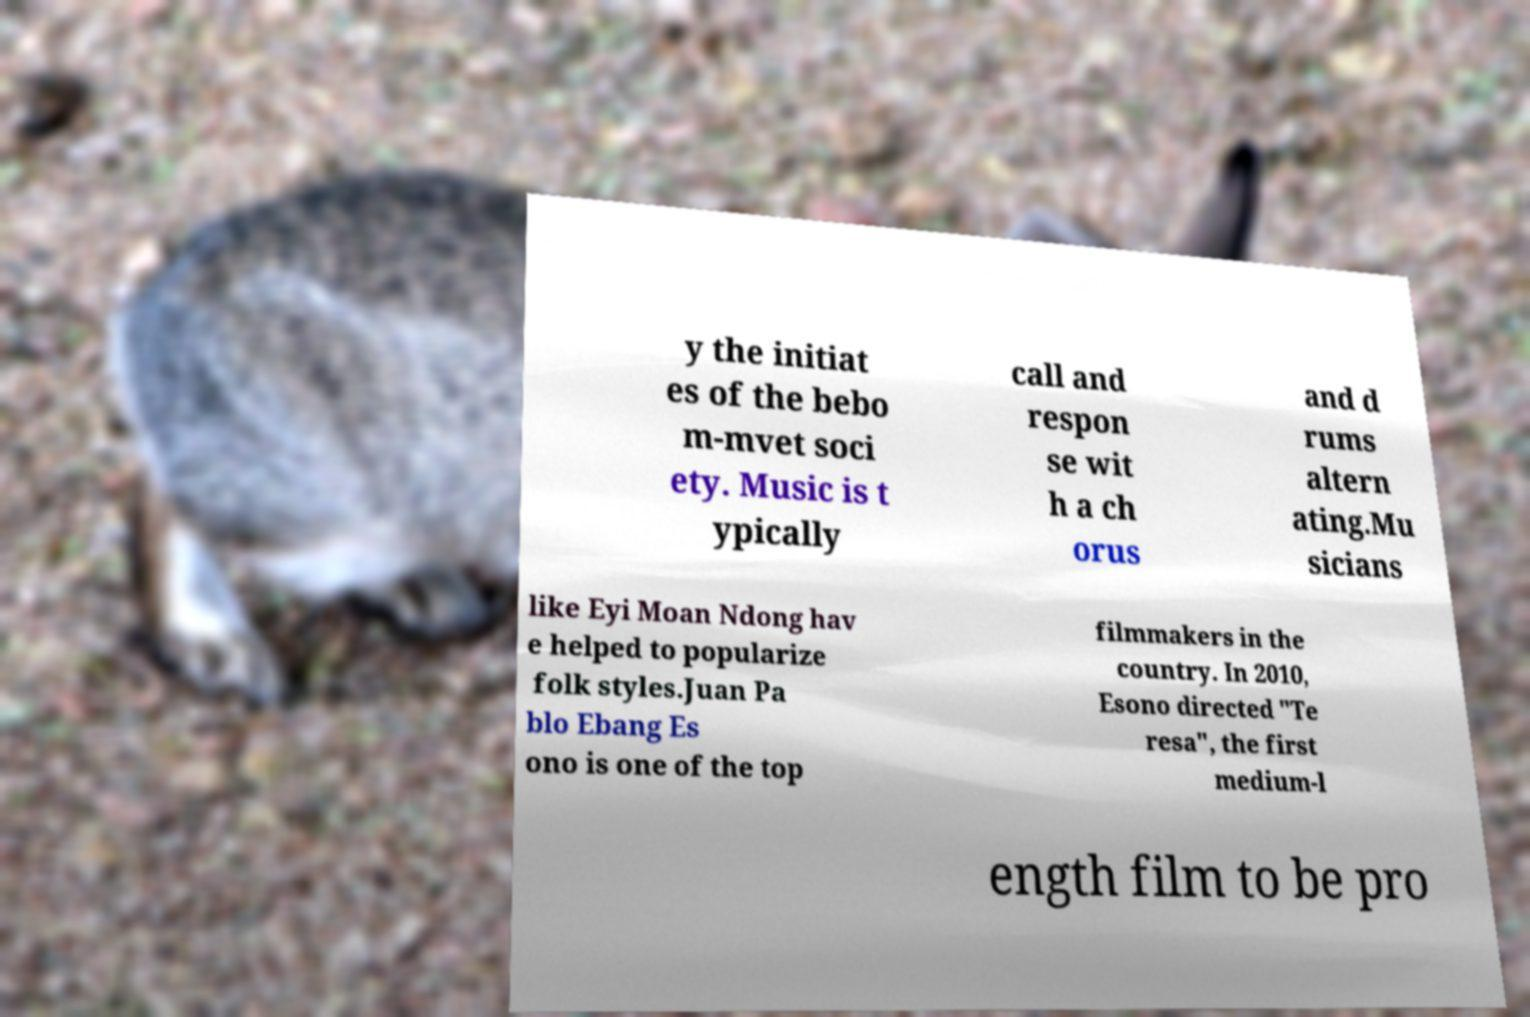Please identify and transcribe the text found in this image. y the initiat es of the bebo m-mvet soci ety. Music is t ypically call and respon se wit h a ch orus and d rums altern ating.Mu sicians like Eyi Moan Ndong hav e helped to popularize folk styles.Juan Pa blo Ebang Es ono is one of the top filmmakers in the country. In 2010, Esono directed "Te resa", the first medium-l ength film to be pro 